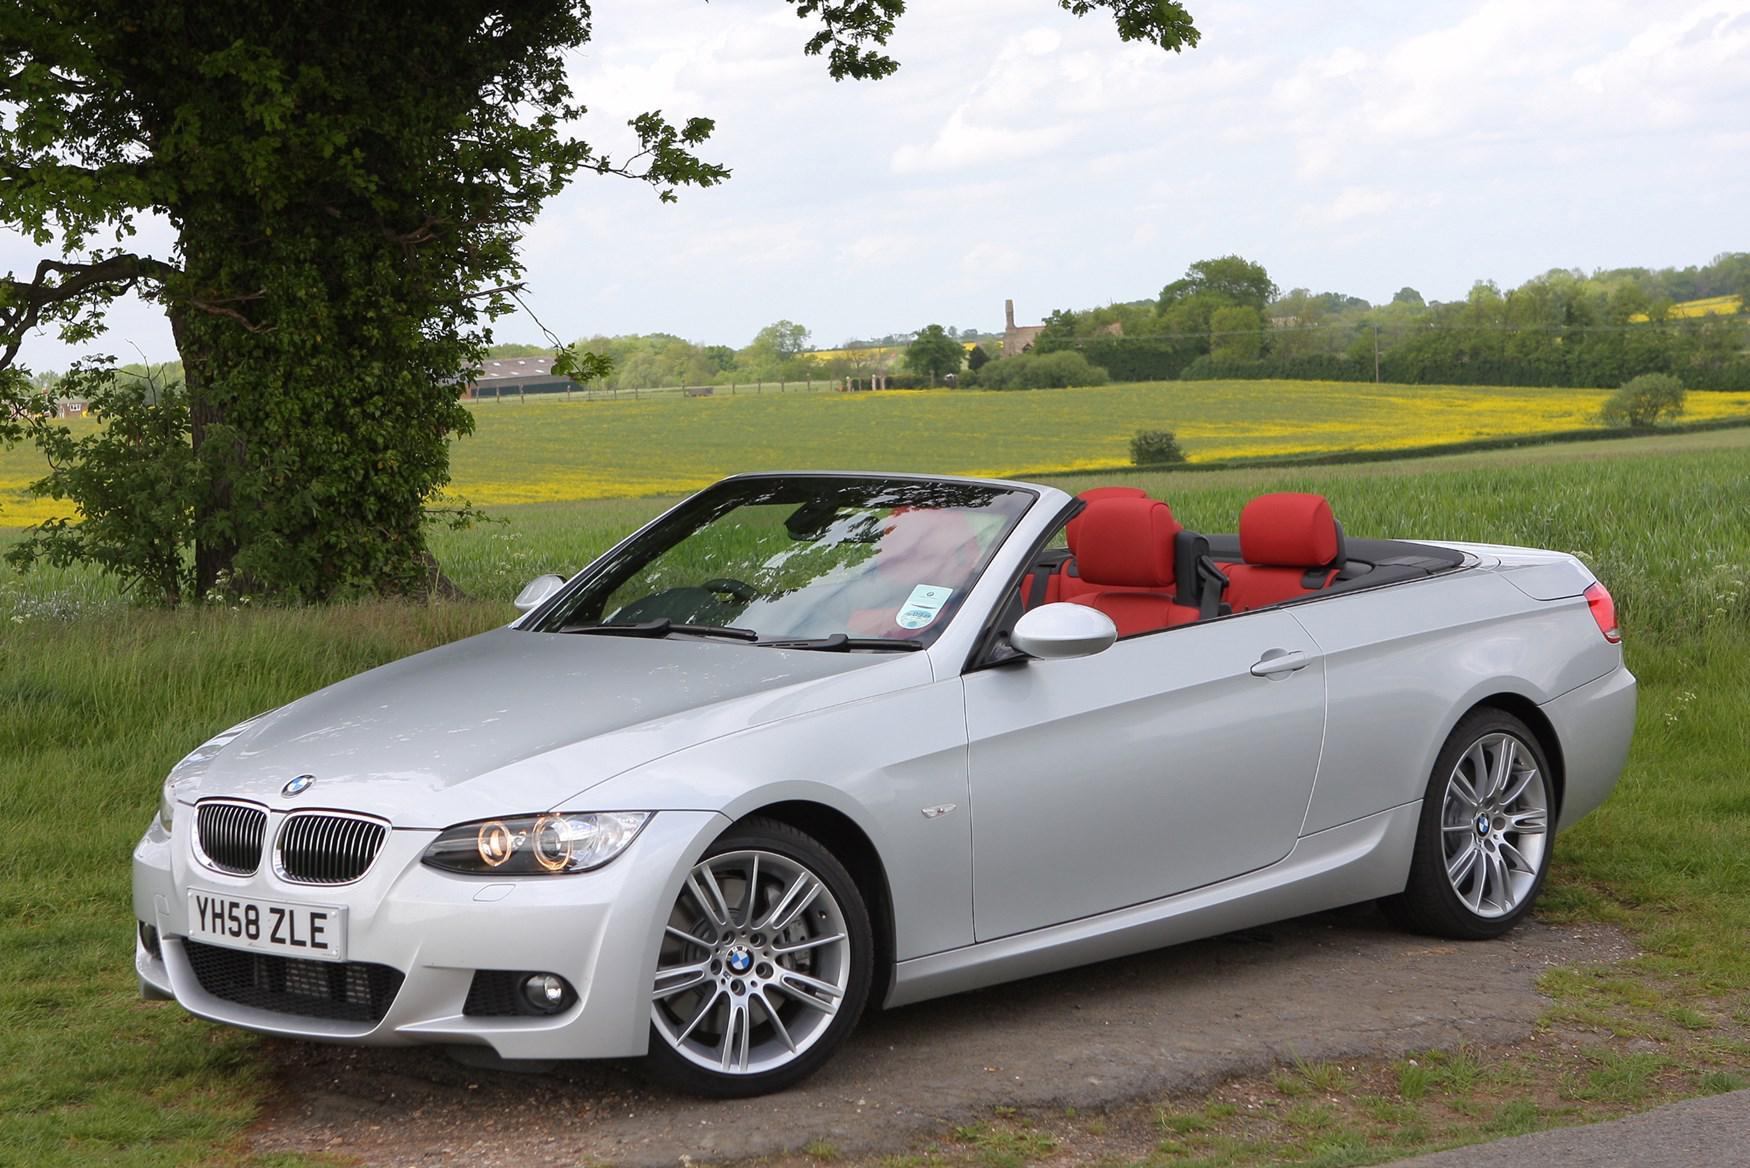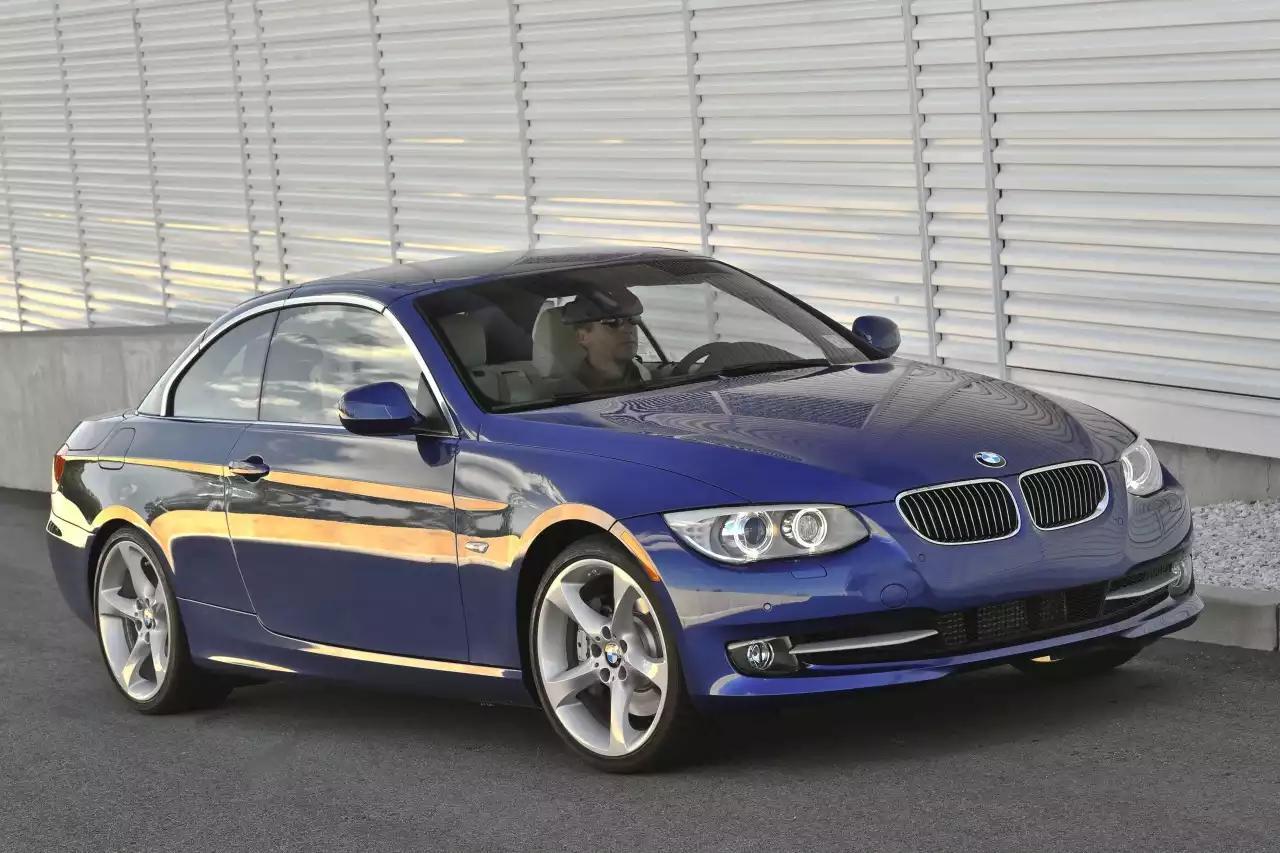The first image is the image on the left, the second image is the image on the right. Given the left and right images, does the statement "In the image on the right, there is a blue car without the top down" hold true? Answer yes or no. Yes. The first image is the image on the left, the second image is the image on the right. Assess this claim about the two images: "Right image contains one blue car, which has a hard top.". Correct or not? Answer yes or no. Yes. 